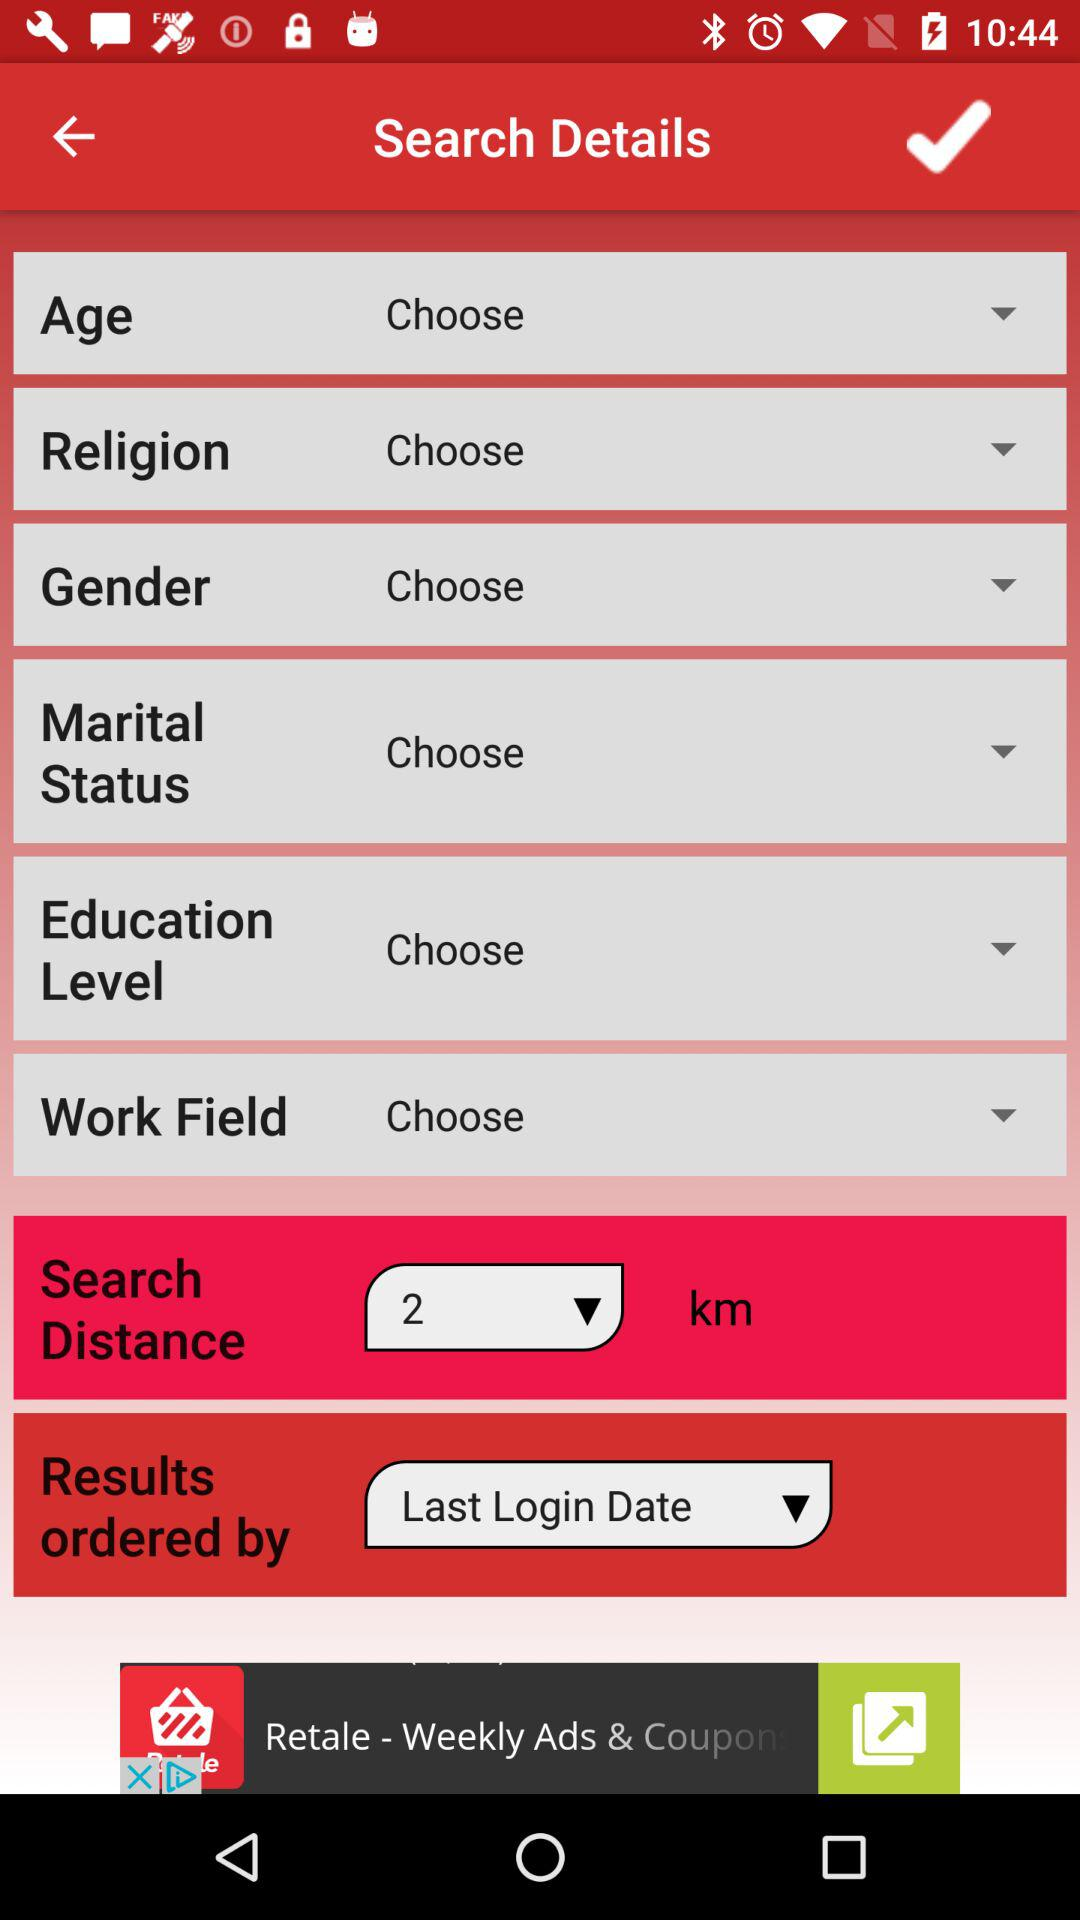What is the distance selected in the drop-down menu? The selected distance is 2 km. 